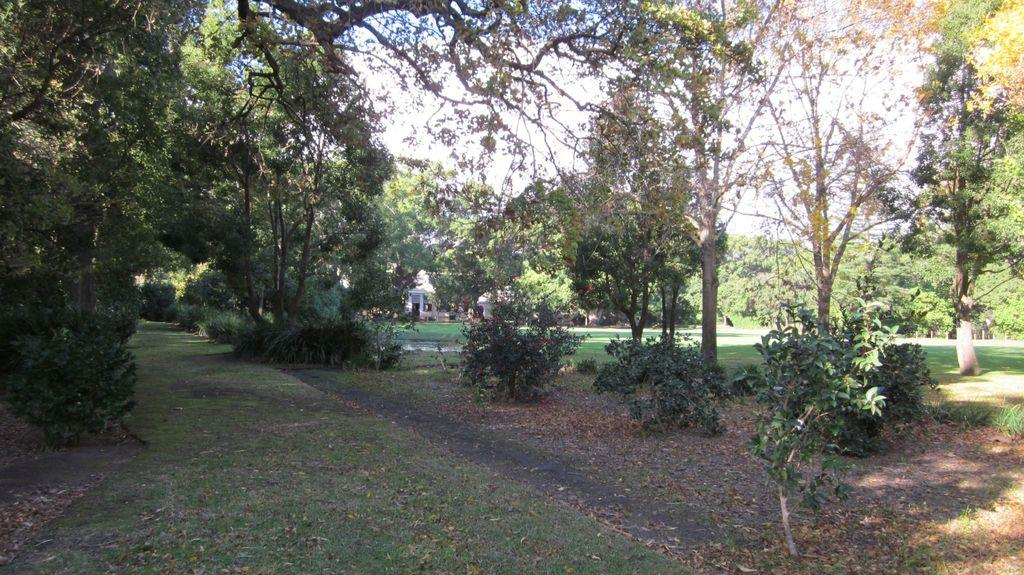What type of vegetation can be seen in the image? There are trees and bushes in the image. What is present on the ground beneath the vegetation? Shredded leaves are present on the ground. What type of structures are visible in the image? There are buildings in the image. What part of the natural environment is visible in the image? The sky is visible in the image. What type of bell can be heard ringing in the image? There is no bell present in the image, and therefore no sound can be heard. 